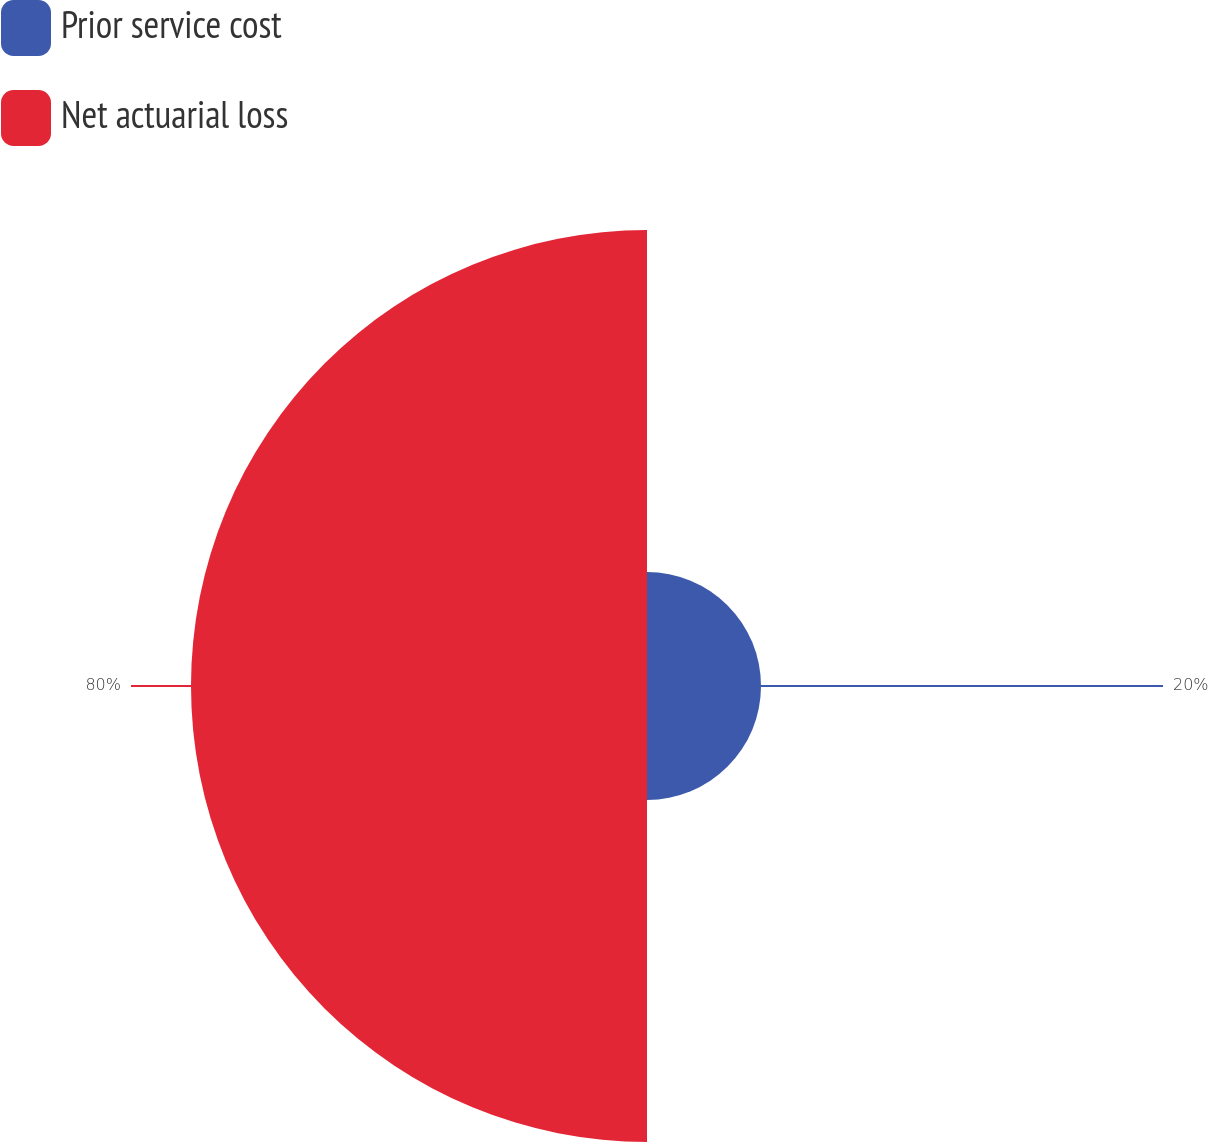<chart> <loc_0><loc_0><loc_500><loc_500><pie_chart><fcel>Prior service cost<fcel>Net actuarial loss<nl><fcel>20.0%<fcel>80.0%<nl></chart> 